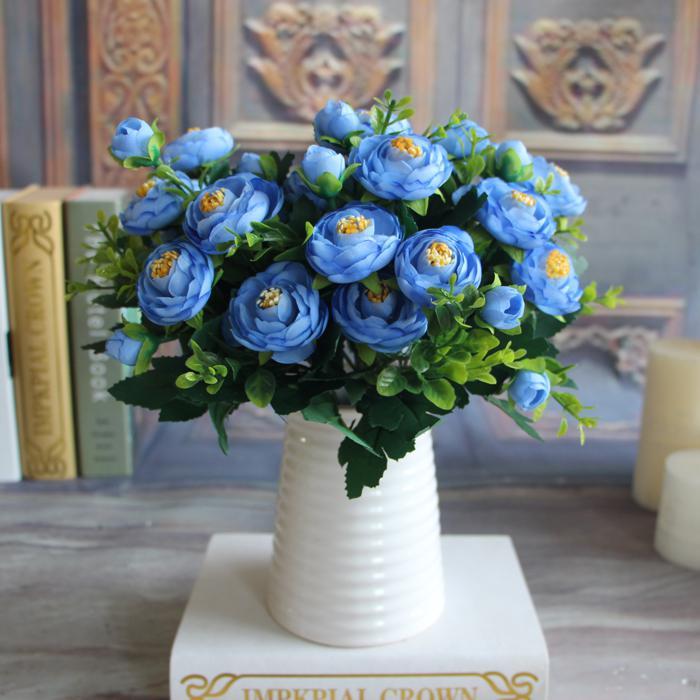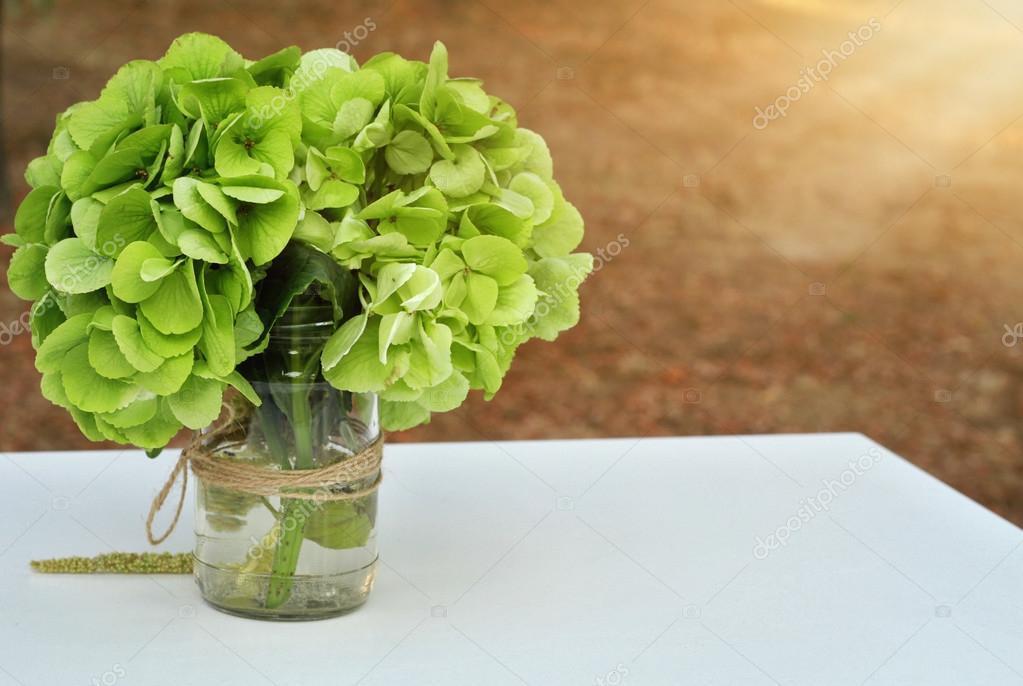The first image is the image on the left, the second image is the image on the right. Assess this claim about the two images: "The flowers in the right photo are placed in an elaborately painted vase.". Correct or not? Answer yes or no. No. The first image is the image on the left, the second image is the image on the right. Examine the images to the left and right. Is the description "One of the floral arrangements has only blue flowers." accurate? Answer yes or no. Yes. 